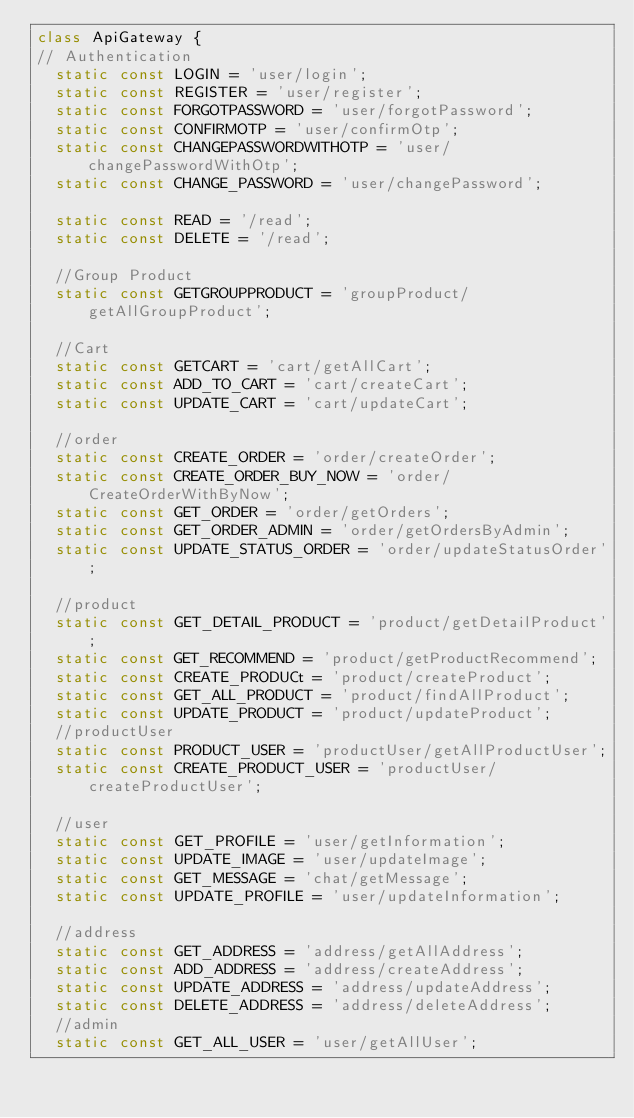Convert code to text. <code><loc_0><loc_0><loc_500><loc_500><_Dart_>class ApiGateway {
// Authentication
  static const LOGIN = 'user/login';
  static const REGISTER = 'user/register';
  static const FORGOTPASSWORD = 'user/forgotPassword';
  static const CONFIRMOTP = 'user/confirmOtp';
  static const CHANGEPASSWORDWITHOTP = 'user/changePasswordWithOtp';
  static const CHANGE_PASSWORD = 'user/changePassword';

  static const READ = '/read';
  static const DELETE = '/read';

  //Group Product
  static const GETGROUPPRODUCT = 'groupProduct/getAllGroupProduct';

  //Cart
  static const GETCART = 'cart/getAllCart';
  static const ADD_TO_CART = 'cart/createCart';
  static const UPDATE_CART = 'cart/updateCart';

  //order
  static const CREATE_ORDER = 'order/createOrder';
  static const CREATE_ORDER_BUY_NOW = 'order/CreateOrderWithByNow';
  static const GET_ORDER = 'order/getOrders';
  static const GET_ORDER_ADMIN = 'order/getOrdersByAdmin';
  static const UPDATE_STATUS_ORDER = 'order/updateStatusOrder';

  //product
  static const GET_DETAIL_PRODUCT = 'product/getDetailProduct';
  static const GET_RECOMMEND = 'product/getProductRecommend';
  static const CREATE_PRODUCt = 'product/createProduct';
  static const GET_ALL_PRODUCT = 'product/findAllProduct';
  static const UPDATE_PRODUCT = 'product/updateProduct';
  //productUser
  static const PRODUCT_USER = 'productUser/getAllProductUser';
  static const CREATE_PRODUCT_USER = 'productUser/createProductUser';

  //user
  static const GET_PROFILE = 'user/getInformation';
  static const UPDATE_IMAGE = 'user/updateImage';
  static const GET_MESSAGE = 'chat/getMessage';
  static const UPDATE_PROFILE = 'user/updateInformation';

  //address
  static const GET_ADDRESS = 'address/getAllAddress';
  static const ADD_ADDRESS = 'address/createAddress';
  static const UPDATE_ADDRESS = 'address/updateAddress';
  static const DELETE_ADDRESS = 'address/deleteAddress';
  //admin
  static const GET_ALL_USER = 'user/getAllUser';</code> 